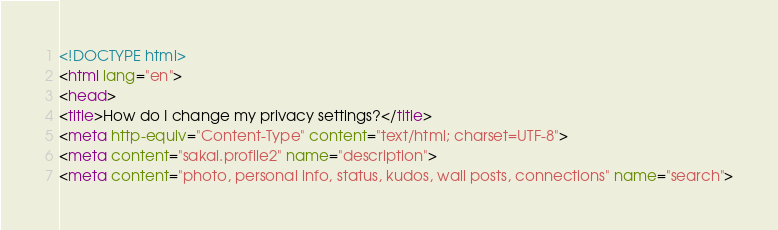Convert code to text. <code><loc_0><loc_0><loc_500><loc_500><_HTML_><!DOCTYPE html>
<html lang="en">
<head>
<title>How do I change my privacy settings?</title>
<meta http-equiv="Content-Type" content="text/html; charset=UTF-8">
<meta content="sakai.profile2" name="description">
<meta content="photo, personal info, status, kudos, wall posts, connections" name="search"></code> 